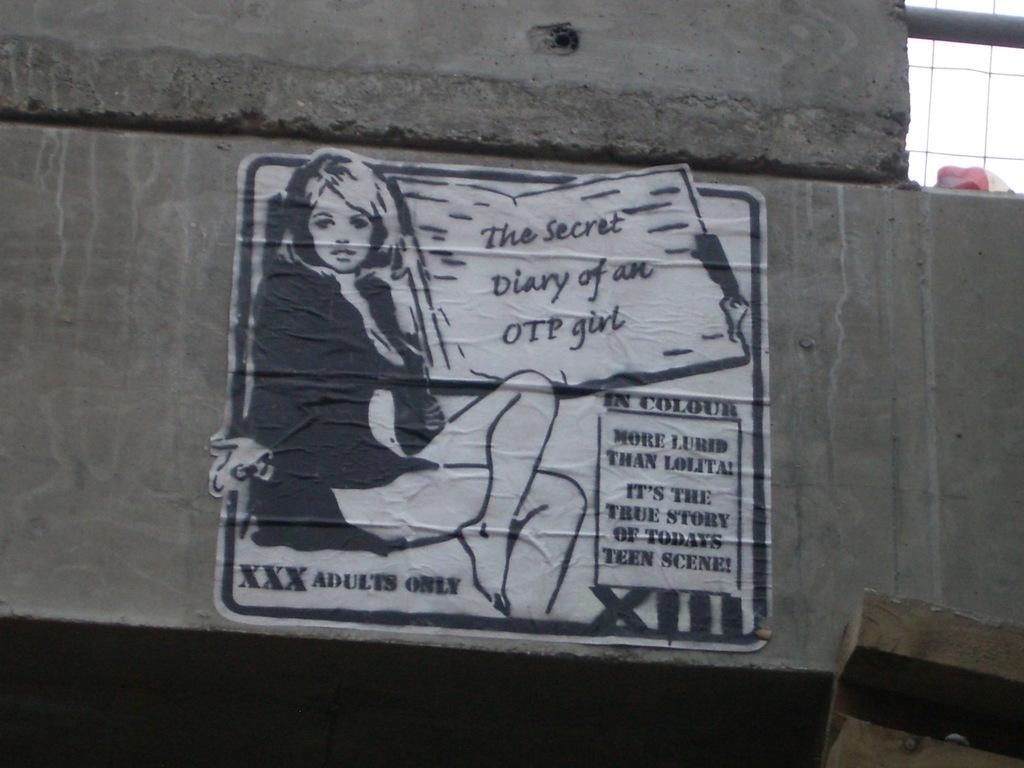What is present on the wall in the image? There is a paper pasted on the wall. What can be seen on the paper? The paper contains a depiction of a person. Is there any text on the paper? Yes, the paper has some text on it. What time of day is depicted in the image? The time of day is not depicted in the image, as it only shows a wall with a paper pasted on it. 